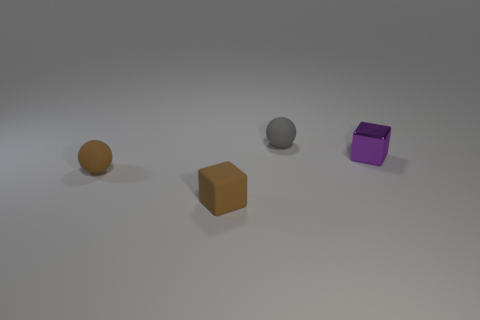There is a small cube that is in front of the tiny purple metallic block; is its color the same as the ball left of the tiny gray sphere?
Offer a very short reply. Yes. What number of tiny matte things are left of the small gray rubber sphere and behind the tiny metal cube?
Keep it short and to the point. 0. What is the material of the purple thing?
Ensure brevity in your answer.  Metal. What is the shape of the gray matte thing that is the same size as the brown ball?
Provide a succinct answer. Sphere. Is the tiny gray ball left of the tiny purple cube made of the same material as the small cube that is behind the tiny brown rubber ball?
Provide a short and direct response. No. What number of matte balls are there?
Keep it short and to the point. 2. What number of small blue things have the same shape as the small gray matte thing?
Your answer should be compact. 0. Does the small shiny thing have the same shape as the small gray matte thing?
Keep it short and to the point. No. What is the size of the gray sphere?
Offer a terse response. Small. How many purple shiny objects are the same size as the gray rubber ball?
Your answer should be compact. 1. 